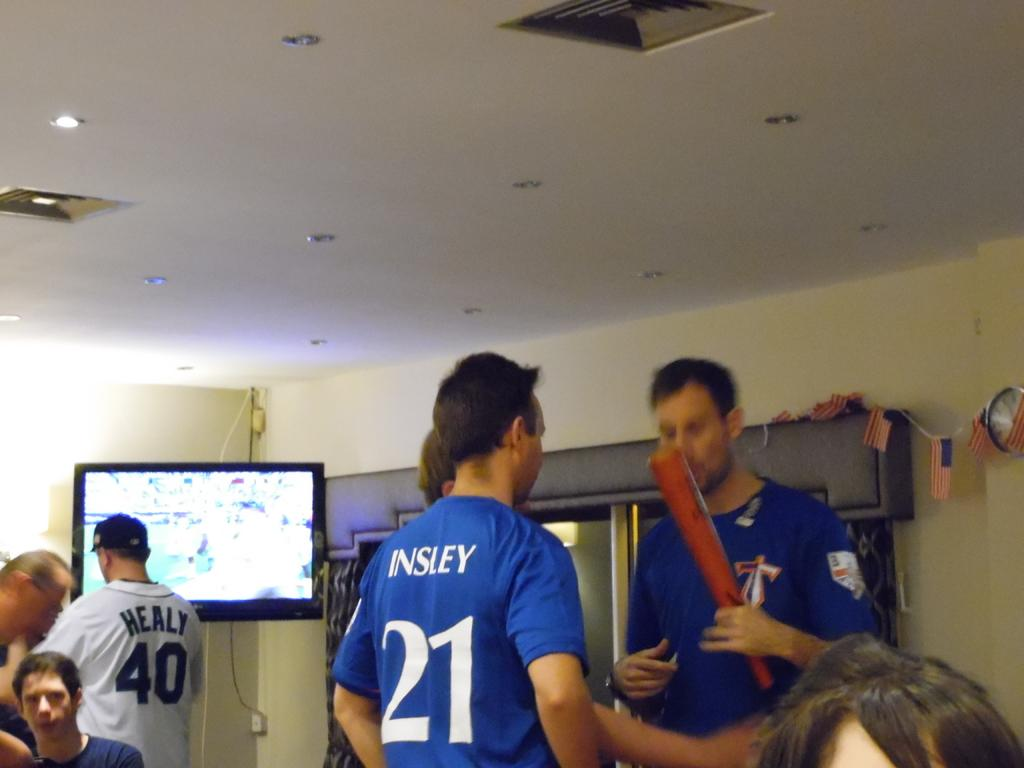<image>
Create a compact narrative representing the image presented. A guy wears a blue shirt with the number 21 on the back. 